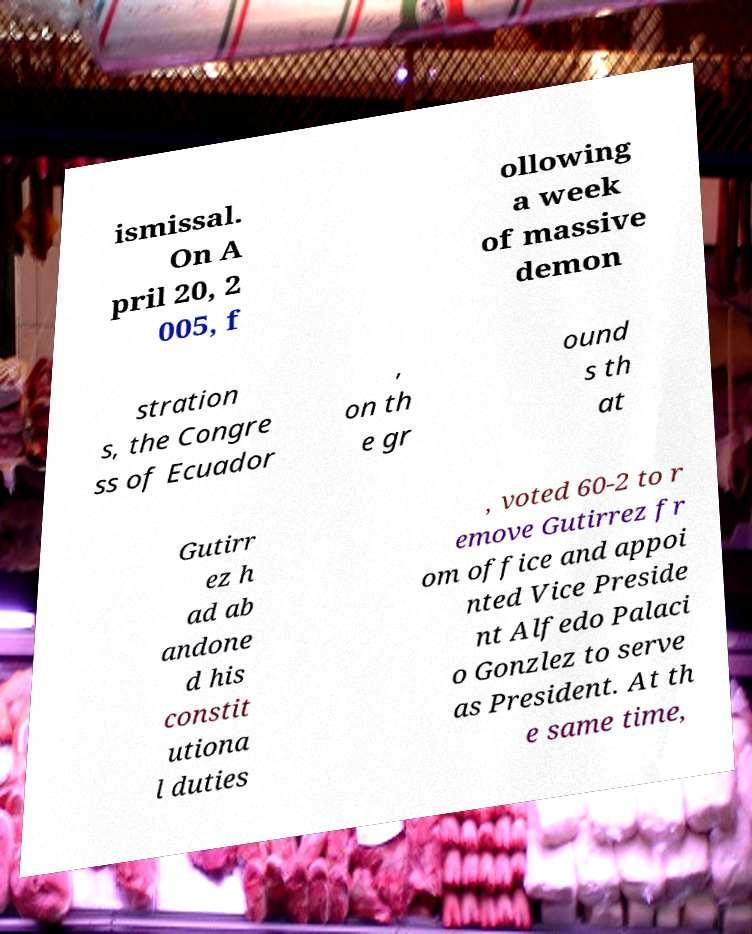Could you assist in decoding the text presented in this image and type it out clearly? ismissal. On A pril 20, 2 005, f ollowing a week of massive demon stration s, the Congre ss of Ecuador , on th e gr ound s th at Gutirr ez h ad ab andone d his constit utiona l duties , voted 60-2 to r emove Gutirrez fr om office and appoi nted Vice Preside nt Alfedo Palaci o Gonzlez to serve as President. At th e same time, 